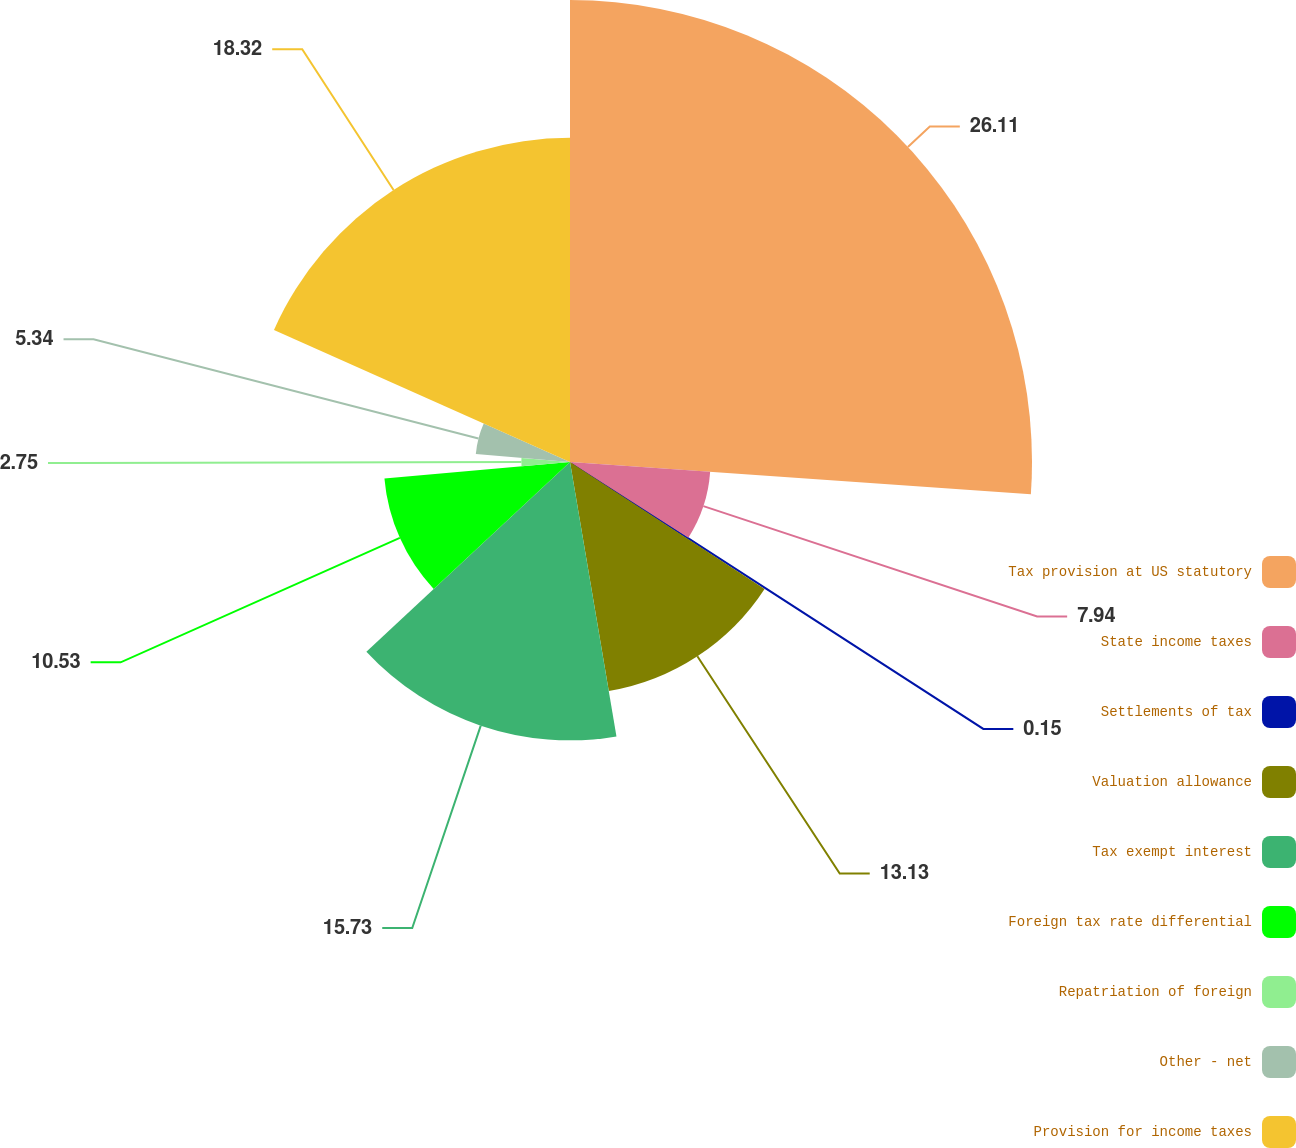Convert chart to OTSL. <chart><loc_0><loc_0><loc_500><loc_500><pie_chart><fcel>Tax provision at US statutory<fcel>State income taxes<fcel>Settlements of tax<fcel>Valuation allowance<fcel>Tax exempt interest<fcel>Foreign tax rate differential<fcel>Repatriation of foreign<fcel>Other - net<fcel>Provision for income taxes<nl><fcel>26.11%<fcel>7.94%<fcel>0.15%<fcel>13.13%<fcel>15.73%<fcel>10.53%<fcel>2.75%<fcel>5.34%<fcel>18.32%<nl></chart> 